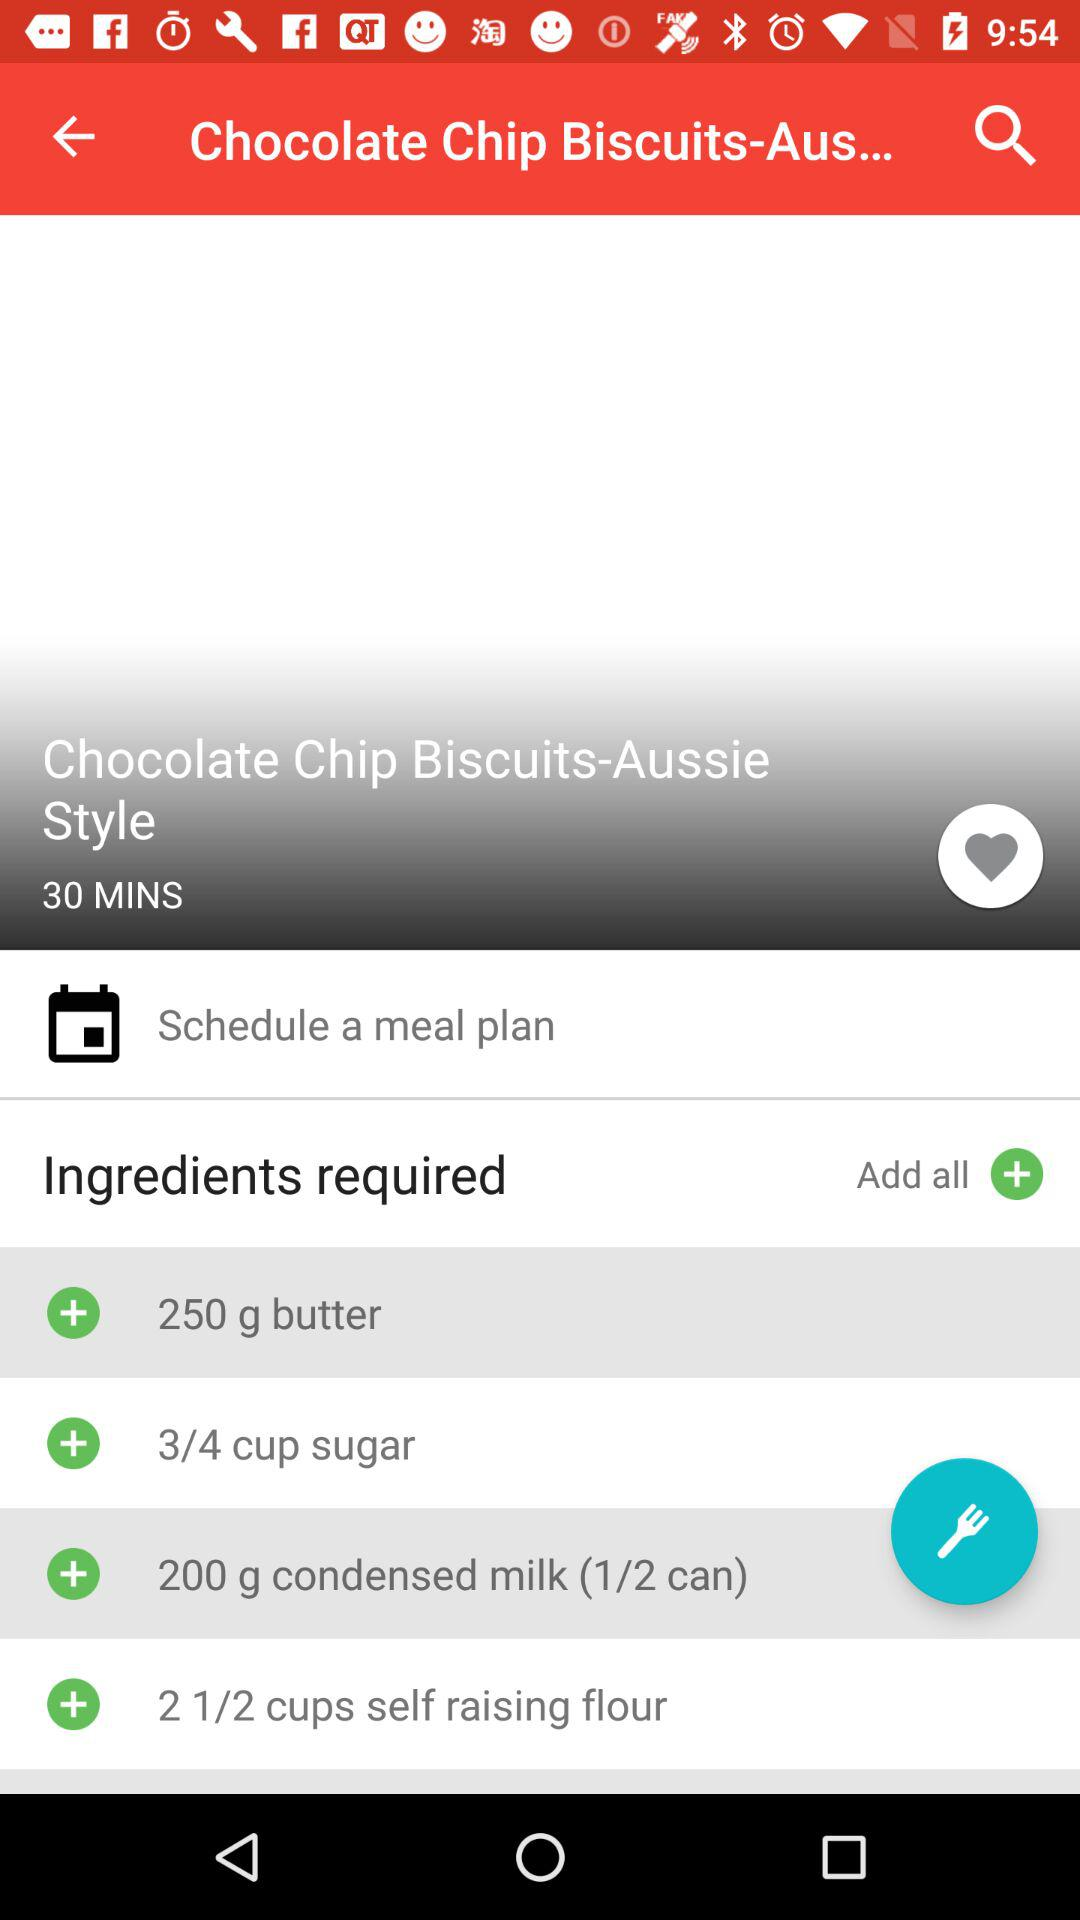What is the cooking time for the "Chocolate Chip Biscuits"? The cooking time is 30 minutes. 